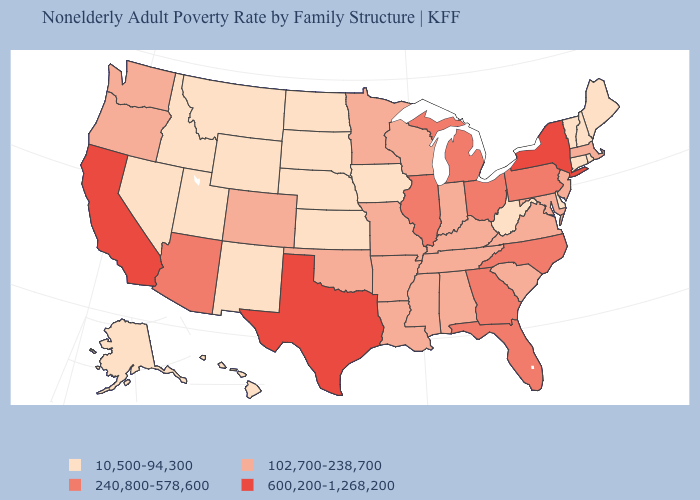Which states have the lowest value in the MidWest?
Concise answer only. Iowa, Kansas, Nebraska, North Dakota, South Dakota. Among the states that border Kentucky , which have the lowest value?
Keep it brief. West Virginia. What is the highest value in the USA?
Give a very brief answer. 600,200-1,268,200. Name the states that have a value in the range 600,200-1,268,200?
Answer briefly. California, New York, Texas. Name the states that have a value in the range 240,800-578,600?
Answer briefly. Arizona, Florida, Georgia, Illinois, Michigan, North Carolina, Ohio, Pennsylvania. Which states have the lowest value in the USA?
Give a very brief answer. Alaska, Connecticut, Delaware, Hawaii, Idaho, Iowa, Kansas, Maine, Montana, Nebraska, Nevada, New Hampshire, New Mexico, North Dakota, Rhode Island, South Dakota, Utah, Vermont, West Virginia, Wyoming. Which states hav the highest value in the MidWest?
Be succinct. Illinois, Michigan, Ohio. Which states have the highest value in the USA?
Concise answer only. California, New York, Texas. Name the states that have a value in the range 600,200-1,268,200?
Short answer required. California, New York, Texas. Does Missouri have the lowest value in the MidWest?
Answer briefly. No. Does Rhode Island have the lowest value in the USA?
Give a very brief answer. Yes. Does Nebraska have the highest value in the USA?
Quick response, please. No. Name the states that have a value in the range 240,800-578,600?
Keep it brief. Arizona, Florida, Georgia, Illinois, Michigan, North Carolina, Ohio, Pennsylvania. Does Louisiana have a higher value than North Carolina?
Answer briefly. No. Among the states that border Arizona , does California have the highest value?
Keep it brief. Yes. 